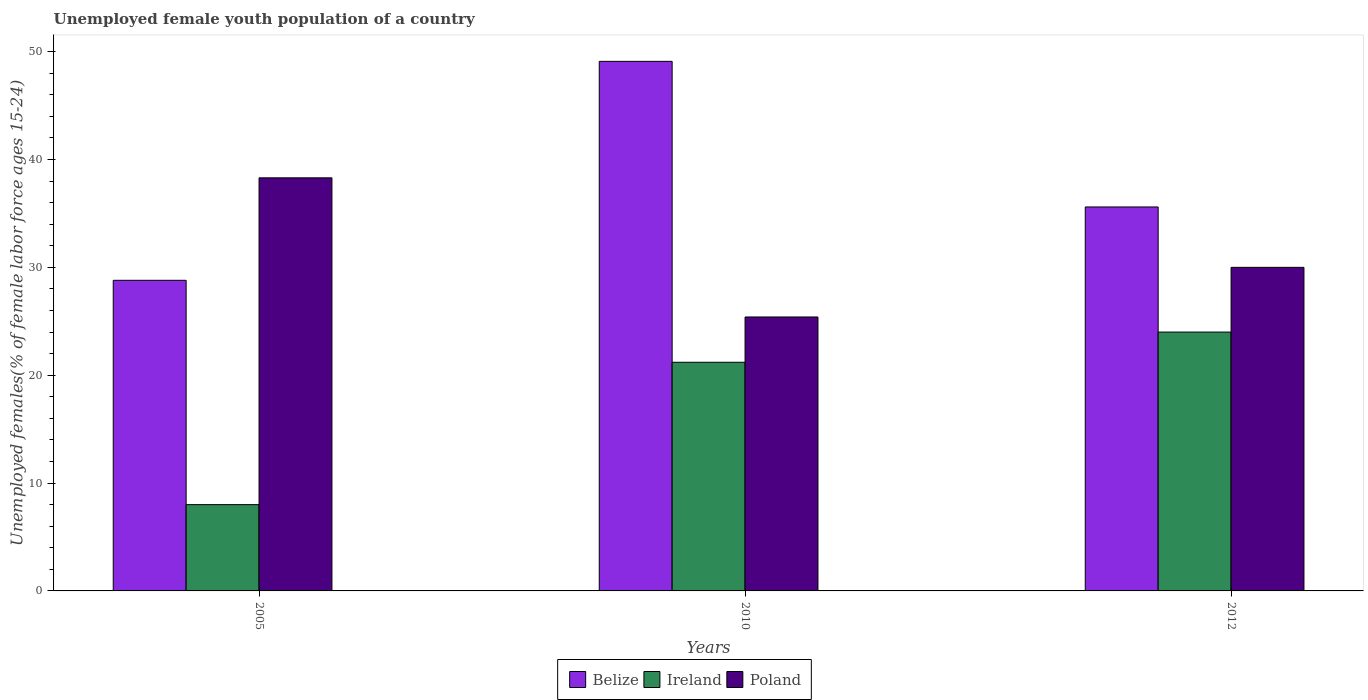How many different coloured bars are there?
Provide a succinct answer. 3. How many groups of bars are there?
Provide a short and direct response. 3. What is the percentage of unemployed female youth population in Poland in 2010?
Provide a succinct answer. 25.4. Across all years, what is the maximum percentage of unemployed female youth population in Belize?
Offer a terse response. 49.1. Across all years, what is the minimum percentage of unemployed female youth population in Poland?
Your answer should be compact. 25.4. What is the total percentage of unemployed female youth population in Ireland in the graph?
Your response must be concise. 53.2. What is the difference between the percentage of unemployed female youth population in Belize in 2005 and that in 2012?
Your answer should be compact. -6.8. What is the difference between the percentage of unemployed female youth population in Ireland in 2010 and the percentage of unemployed female youth population in Belize in 2005?
Your answer should be compact. -7.6. What is the average percentage of unemployed female youth population in Belize per year?
Your response must be concise. 37.83. In the year 2012, what is the difference between the percentage of unemployed female youth population in Belize and percentage of unemployed female youth population in Ireland?
Your answer should be compact. 11.6. In how many years, is the percentage of unemployed female youth population in Poland greater than 32 %?
Your answer should be very brief. 1. What is the ratio of the percentage of unemployed female youth population in Poland in 2005 to that in 2010?
Make the answer very short. 1.51. Is the percentage of unemployed female youth population in Ireland in 2010 less than that in 2012?
Ensure brevity in your answer.  Yes. What is the difference between the highest and the second highest percentage of unemployed female youth population in Ireland?
Offer a terse response. 2.8. What is the difference between the highest and the lowest percentage of unemployed female youth population in Poland?
Give a very brief answer. 12.9. Is the sum of the percentage of unemployed female youth population in Ireland in 2010 and 2012 greater than the maximum percentage of unemployed female youth population in Belize across all years?
Keep it short and to the point. No. What does the 1st bar from the left in 2012 represents?
Ensure brevity in your answer.  Belize. What does the 2nd bar from the right in 2010 represents?
Offer a very short reply. Ireland. Is it the case that in every year, the sum of the percentage of unemployed female youth population in Ireland and percentage of unemployed female youth population in Belize is greater than the percentage of unemployed female youth population in Poland?
Your response must be concise. No. How many years are there in the graph?
Make the answer very short. 3. Are the values on the major ticks of Y-axis written in scientific E-notation?
Offer a very short reply. No. How are the legend labels stacked?
Ensure brevity in your answer.  Horizontal. What is the title of the graph?
Offer a very short reply. Unemployed female youth population of a country. Does "Japan" appear as one of the legend labels in the graph?
Offer a very short reply. No. What is the label or title of the X-axis?
Make the answer very short. Years. What is the label or title of the Y-axis?
Offer a terse response. Unemployed females(% of female labor force ages 15-24). What is the Unemployed females(% of female labor force ages 15-24) in Belize in 2005?
Keep it short and to the point. 28.8. What is the Unemployed females(% of female labor force ages 15-24) in Poland in 2005?
Ensure brevity in your answer.  38.3. What is the Unemployed females(% of female labor force ages 15-24) of Belize in 2010?
Ensure brevity in your answer.  49.1. What is the Unemployed females(% of female labor force ages 15-24) of Ireland in 2010?
Your answer should be very brief. 21.2. What is the Unemployed females(% of female labor force ages 15-24) of Poland in 2010?
Your answer should be very brief. 25.4. What is the Unemployed females(% of female labor force ages 15-24) of Belize in 2012?
Provide a short and direct response. 35.6. Across all years, what is the maximum Unemployed females(% of female labor force ages 15-24) in Belize?
Provide a short and direct response. 49.1. Across all years, what is the maximum Unemployed females(% of female labor force ages 15-24) in Ireland?
Your answer should be compact. 24. Across all years, what is the maximum Unemployed females(% of female labor force ages 15-24) in Poland?
Offer a terse response. 38.3. Across all years, what is the minimum Unemployed females(% of female labor force ages 15-24) of Belize?
Provide a succinct answer. 28.8. Across all years, what is the minimum Unemployed females(% of female labor force ages 15-24) of Ireland?
Keep it short and to the point. 8. Across all years, what is the minimum Unemployed females(% of female labor force ages 15-24) of Poland?
Keep it short and to the point. 25.4. What is the total Unemployed females(% of female labor force ages 15-24) of Belize in the graph?
Ensure brevity in your answer.  113.5. What is the total Unemployed females(% of female labor force ages 15-24) of Ireland in the graph?
Ensure brevity in your answer.  53.2. What is the total Unemployed females(% of female labor force ages 15-24) in Poland in the graph?
Offer a terse response. 93.7. What is the difference between the Unemployed females(% of female labor force ages 15-24) of Belize in 2005 and that in 2010?
Keep it short and to the point. -20.3. What is the difference between the Unemployed females(% of female labor force ages 15-24) of Poland in 2005 and that in 2010?
Keep it short and to the point. 12.9. What is the difference between the Unemployed females(% of female labor force ages 15-24) in Poland in 2005 and that in 2012?
Offer a very short reply. 8.3. What is the difference between the Unemployed females(% of female labor force ages 15-24) of Belize in 2010 and that in 2012?
Offer a terse response. 13.5. What is the difference between the Unemployed females(% of female labor force ages 15-24) in Belize in 2005 and the Unemployed females(% of female labor force ages 15-24) in Poland in 2010?
Ensure brevity in your answer.  3.4. What is the difference between the Unemployed females(% of female labor force ages 15-24) in Ireland in 2005 and the Unemployed females(% of female labor force ages 15-24) in Poland in 2010?
Your answer should be compact. -17.4. What is the difference between the Unemployed females(% of female labor force ages 15-24) of Belize in 2005 and the Unemployed females(% of female labor force ages 15-24) of Ireland in 2012?
Provide a succinct answer. 4.8. What is the difference between the Unemployed females(% of female labor force ages 15-24) of Ireland in 2005 and the Unemployed females(% of female labor force ages 15-24) of Poland in 2012?
Provide a succinct answer. -22. What is the difference between the Unemployed females(% of female labor force ages 15-24) of Belize in 2010 and the Unemployed females(% of female labor force ages 15-24) of Ireland in 2012?
Give a very brief answer. 25.1. What is the difference between the Unemployed females(% of female labor force ages 15-24) in Belize in 2010 and the Unemployed females(% of female labor force ages 15-24) in Poland in 2012?
Keep it short and to the point. 19.1. What is the average Unemployed females(% of female labor force ages 15-24) of Belize per year?
Give a very brief answer. 37.83. What is the average Unemployed females(% of female labor force ages 15-24) of Ireland per year?
Your answer should be very brief. 17.73. What is the average Unemployed females(% of female labor force ages 15-24) of Poland per year?
Your answer should be compact. 31.23. In the year 2005, what is the difference between the Unemployed females(% of female labor force ages 15-24) in Belize and Unemployed females(% of female labor force ages 15-24) in Ireland?
Provide a succinct answer. 20.8. In the year 2005, what is the difference between the Unemployed females(% of female labor force ages 15-24) of Belize and Unemployed females(% of female labor force ages 15-24) of Poland?
Provide a short and direct response. -9.5. In the year 2005, what is the difference between the Unemployed females(% of female labor force ages 15-24) of Ireland and Unemployed females(% of female labor force ages 15-24) of Poland?
Keep it short and to the point. -30.3. In the year 2010, what is the difference between the Unemployed females(% of female labor force ages 15-24) of Belize and Unemployed females(% of female labor force ages 15-24) of Ireland?
Provide a succinct answer. 27.9. In the year 2010, what is the difference between the Unemployed females(% of female labor force ages 15-24) in Belize and Unemployed females(% of female labor force ages 15-24) in Poland?
Provide a succinct answer. 23.7. In the year 2010, what is the difference between the Unemployed females(% of female labor force ages 15-24) of Ireland and Unemployed females(% of female labor force ages 15-24) of Poland?
Provide a succinct answer. -4.2. What is the ratio of the Unemployed females(% of female labor force ages 15-24) in Belize in 2005 to that in 2010?
Your answer should be compact. 0.59. What is the ratio of the Unemployed females(% of female labor force ages 15-24) in Ireland in 2005 to that in 2010?
Provide a succinct answer. 0.38. What is the ratio of the Unemployed females(% of female labor force ages 15-24) of Poland in 2005 to that in 2010?
Your response must be concise. 1.51. What is the ratio of the Unemployed females(% of female labor force ages 15-24) in Belize in 2005 to that in 2012?
Keep it short and to the point. 0.81. What is the ratio of the Unemployed females(% of female labor force ages 15-24) in Poland in 2005 to that in 2012?
Your response must be concise. 1.28. What is the ratio of the Unemployed females(% of female labor force ages 15-24) of Belize in 2010 to that in 2012?
Provide a short and direct response. 1.38. What is the ratio of the Unemployed females(% of female labor force ages 15-24) in Ireland in 2010 to that in 2012?
Offer a terse response. 0.88. What is the ratio of the Unemployed females(% of female labor force ages 15-24) in Poland in 2010 to that in 2012?
Provide a succinct answer. 0.85. What is the difference between the highest and the second highest Unemployed females(% of female labor force ages 15-24) in Poland?
Provide a short and direct response. 8.3. What is the difference between the highest and the lowest Unemployed females(% of female labor force ages 15-24) of Belize?
Your response must be concise. 20.3. What is the difference between the highest and the lowest Unemployed females(% of female labor force ages 15-24) in Ireland?
Your response must be concise. 16. 